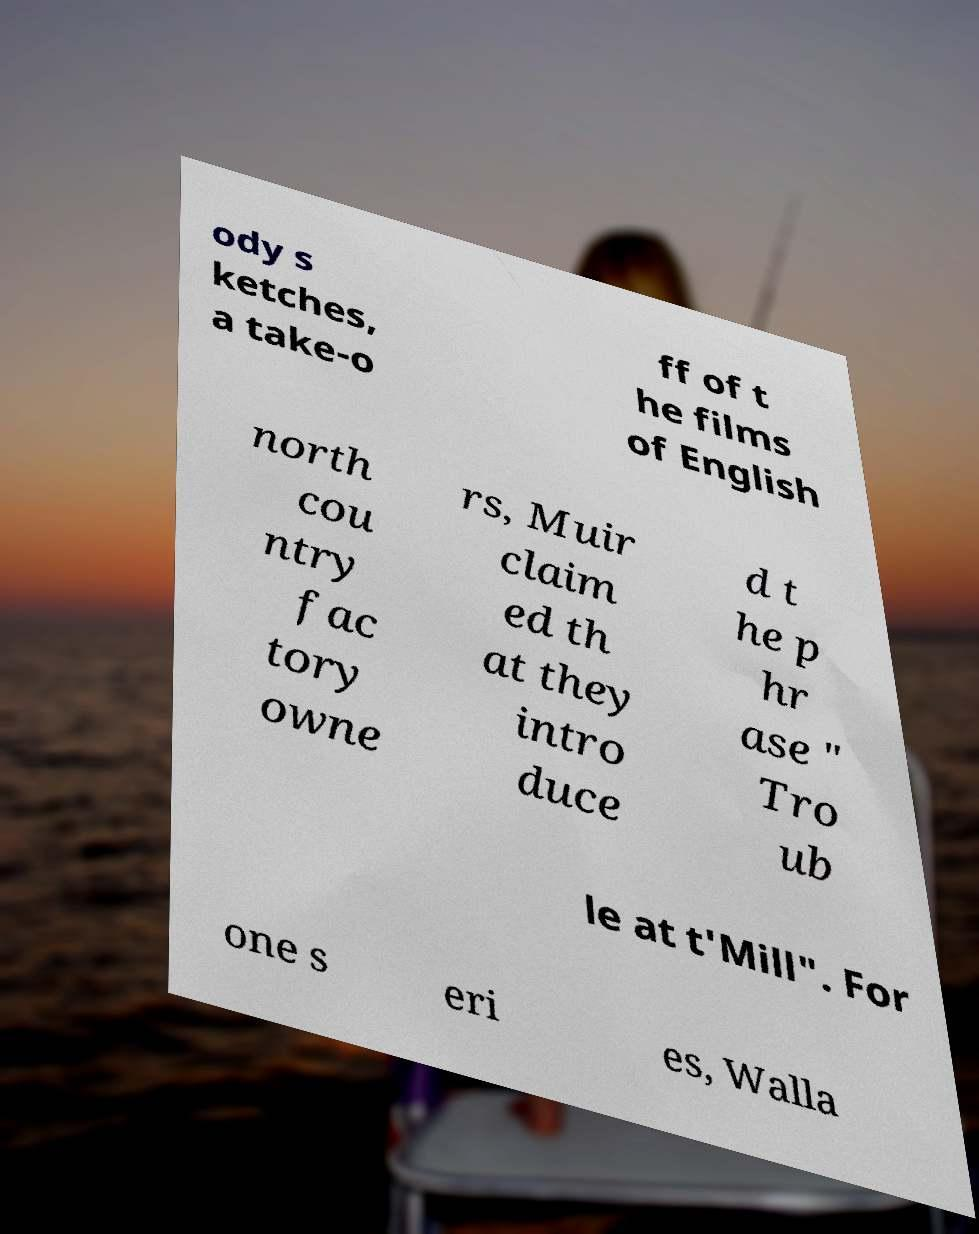Can you read and provide the text displayed in the image?This photo seems to have some interesting text. Can you extract and type it out for me? ody s ketches, a take-o ff of t he films of English north cou ntry fac tory owne rs, Muir claim ed th at they intro duce d t he p hr ase " Tro ub le at t'Mill". For one s eri es, Walla 